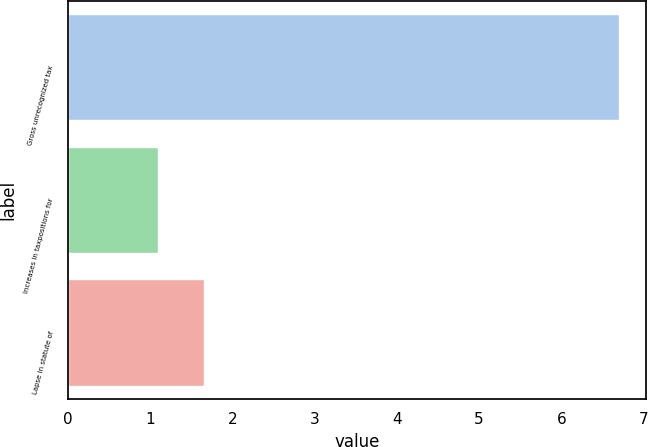Convert chart to OTSL. <chart><loc_0><loc_0><loc_500><loc_500><bar_chart><fcel>Gross unrecognized tax<fcel>Increases in taxpositions for<fcel>Lapse in statute of<nl><fcel>6.7<fcel>1.1<fcel>1.66<nl></chart> 